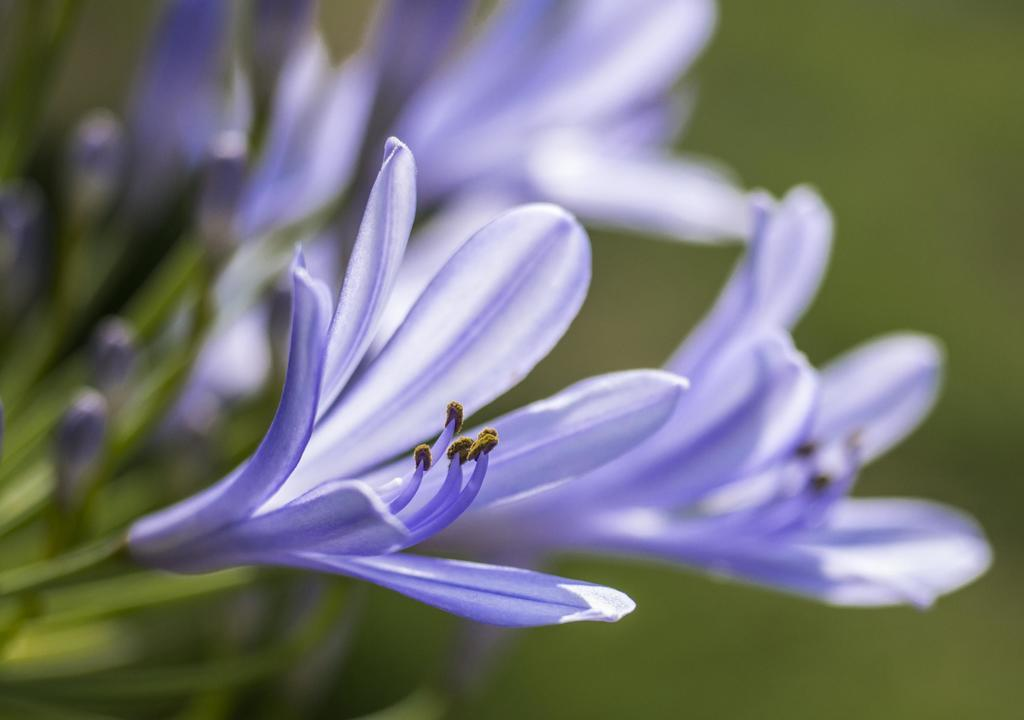What type of flowers can be seen in the foreground of the image? There are violet flowers in the foreground of the image. What are the flowers a part of? The flowers are associated with plants. What story is being told by the zinc in the image? There is no zinc present in the image, and therefore no story can be told by it. 